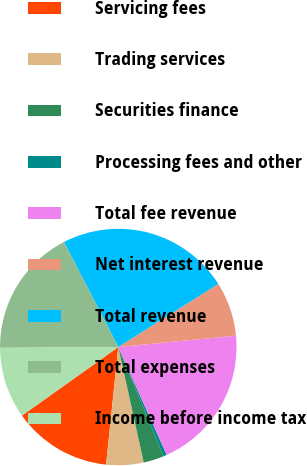Convert chart to OTSL. <chart><loc_0><loc_0><loc_500><loc_500><pie_chart><fcel>Servicing fees<fcel>Trading services<fcel>Securities finance<fcel>Processing fees and other<fcel>Total fee revenue<fcel>Net interest revenue<fcel>Total revenue<fcel>Total expenses<fcel>Income before income tax<nl><fcel>13.51%<fcel>5.1%<fcel>2.79%<fcel>0.47%<fcel>19.82%<fcel>7.42%<fcel>23.64%<fcel>17.51%<fcel>9.74%<nl></chart> 